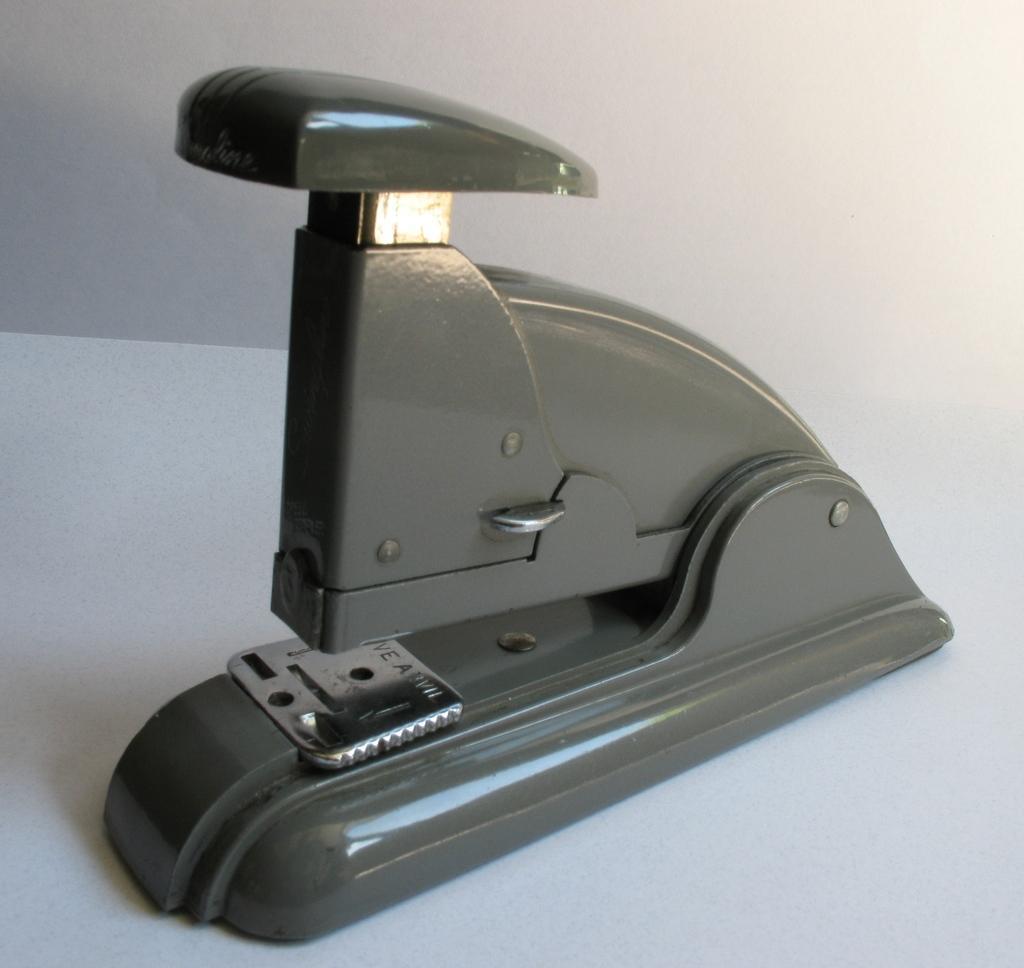How would you summarize this image in a sentence or two? As we can see in the image there is a wall and table. On table there is a paper hole punch. 